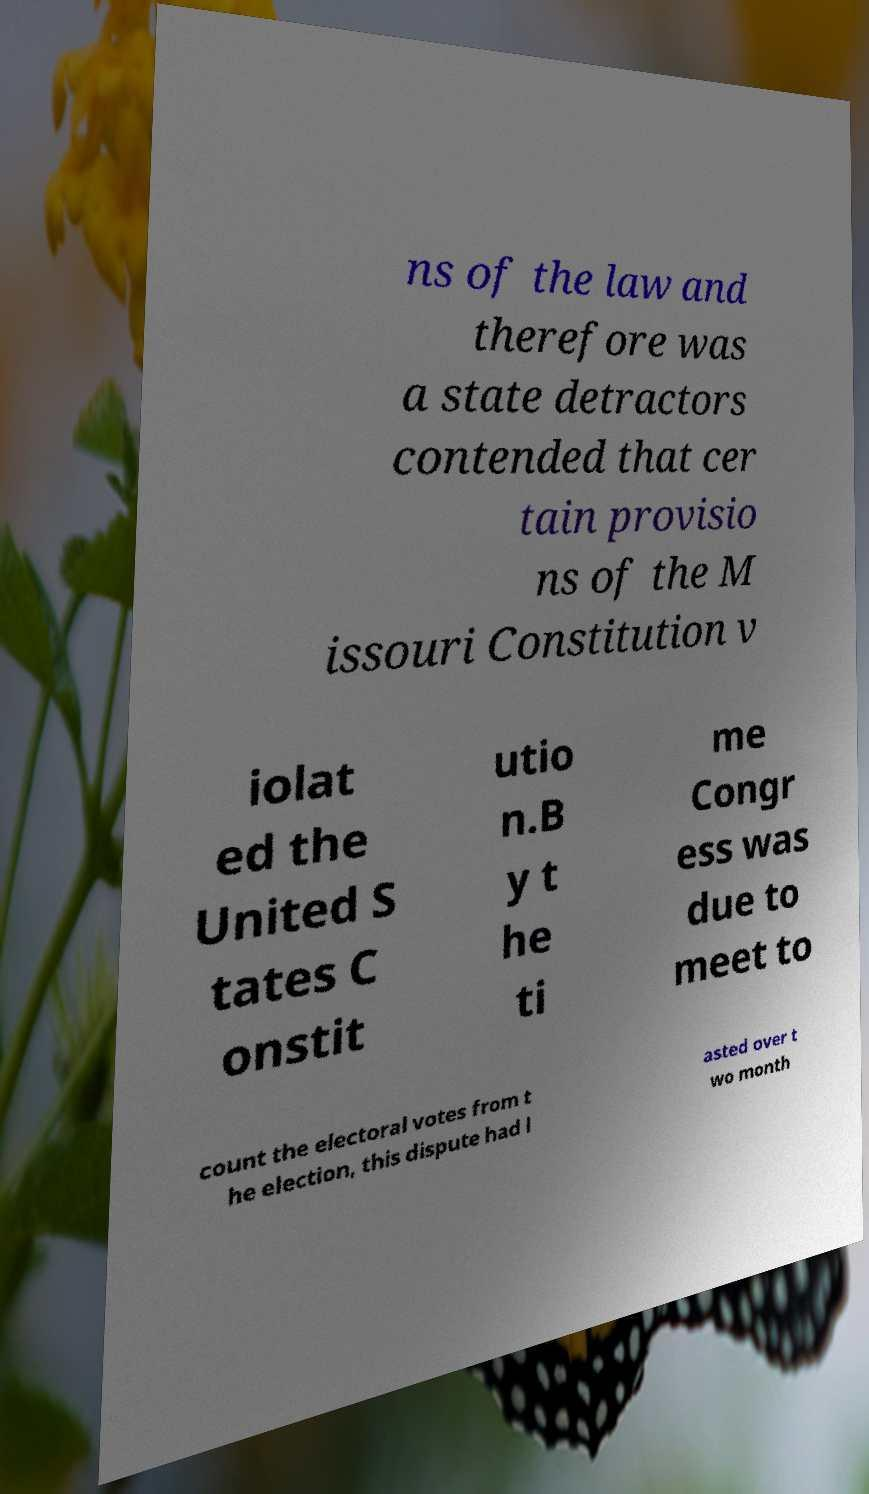Could you extract and type out the text from this image? ns of the law and therefore was a state detractors contended that cer tain provisio ns of the M issouri Constitution v iolat ed the United S tates C onstit utio n.B y t he ti me Congr ess was due to meet to count the electoral votes from t he election, this dispute had l asted over t wo month 